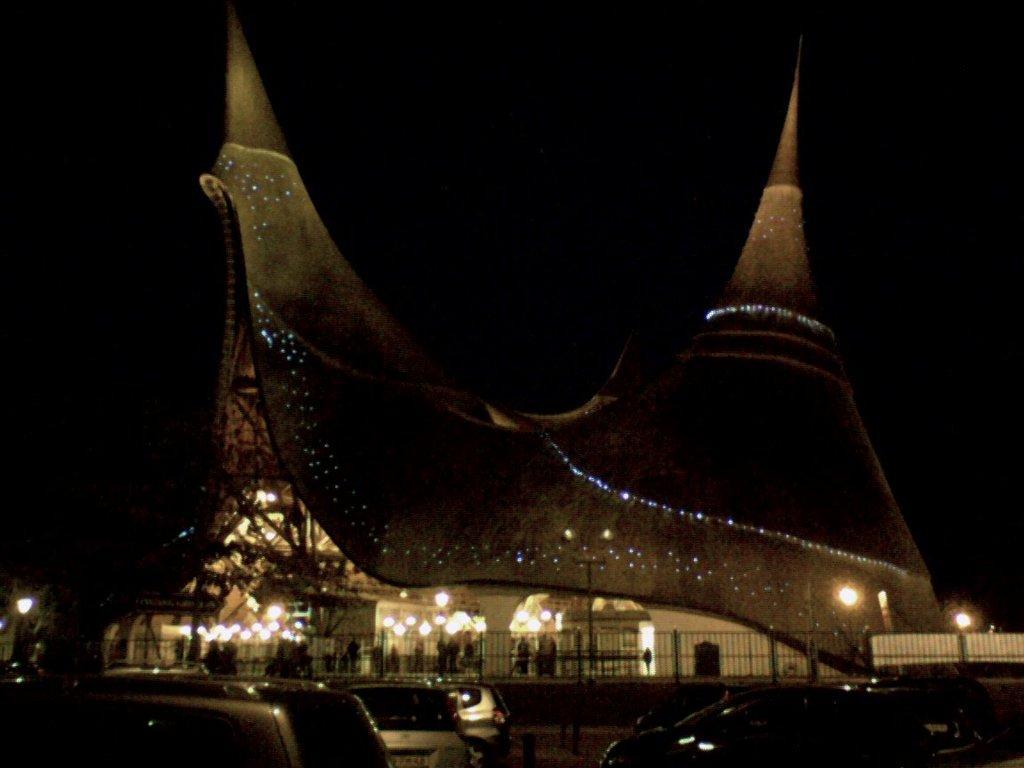Please provide a concise description of this image. In this image we can see the building with lights and there are people standing. There are vehicles, fence, and pole. And there is the dark background. 